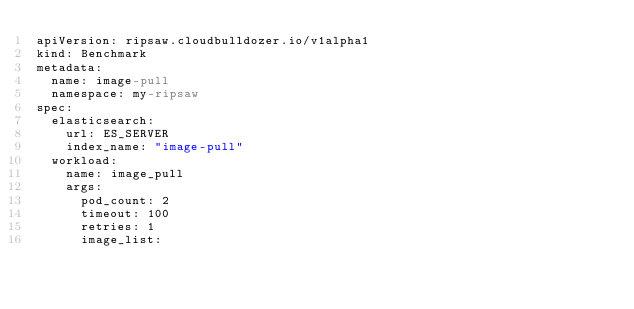Convert code to text. <code><loc_0><loc_0><loc_500><loc_500><_YAML_>apiVersion: ripsaw.cloudbulldozer.io/v1alpha1
kind: Benchmark
metadata:
  name: image-pull
  namespace: my-ripsaw
spec:
  elasticsearch:
    url: ES_SERVER
    index_name: "image-pull"
  workload:
    name: image_pull
    args:
      pod_count: 2
      timeout: 100
      retries: 1
      image_list:</code> 